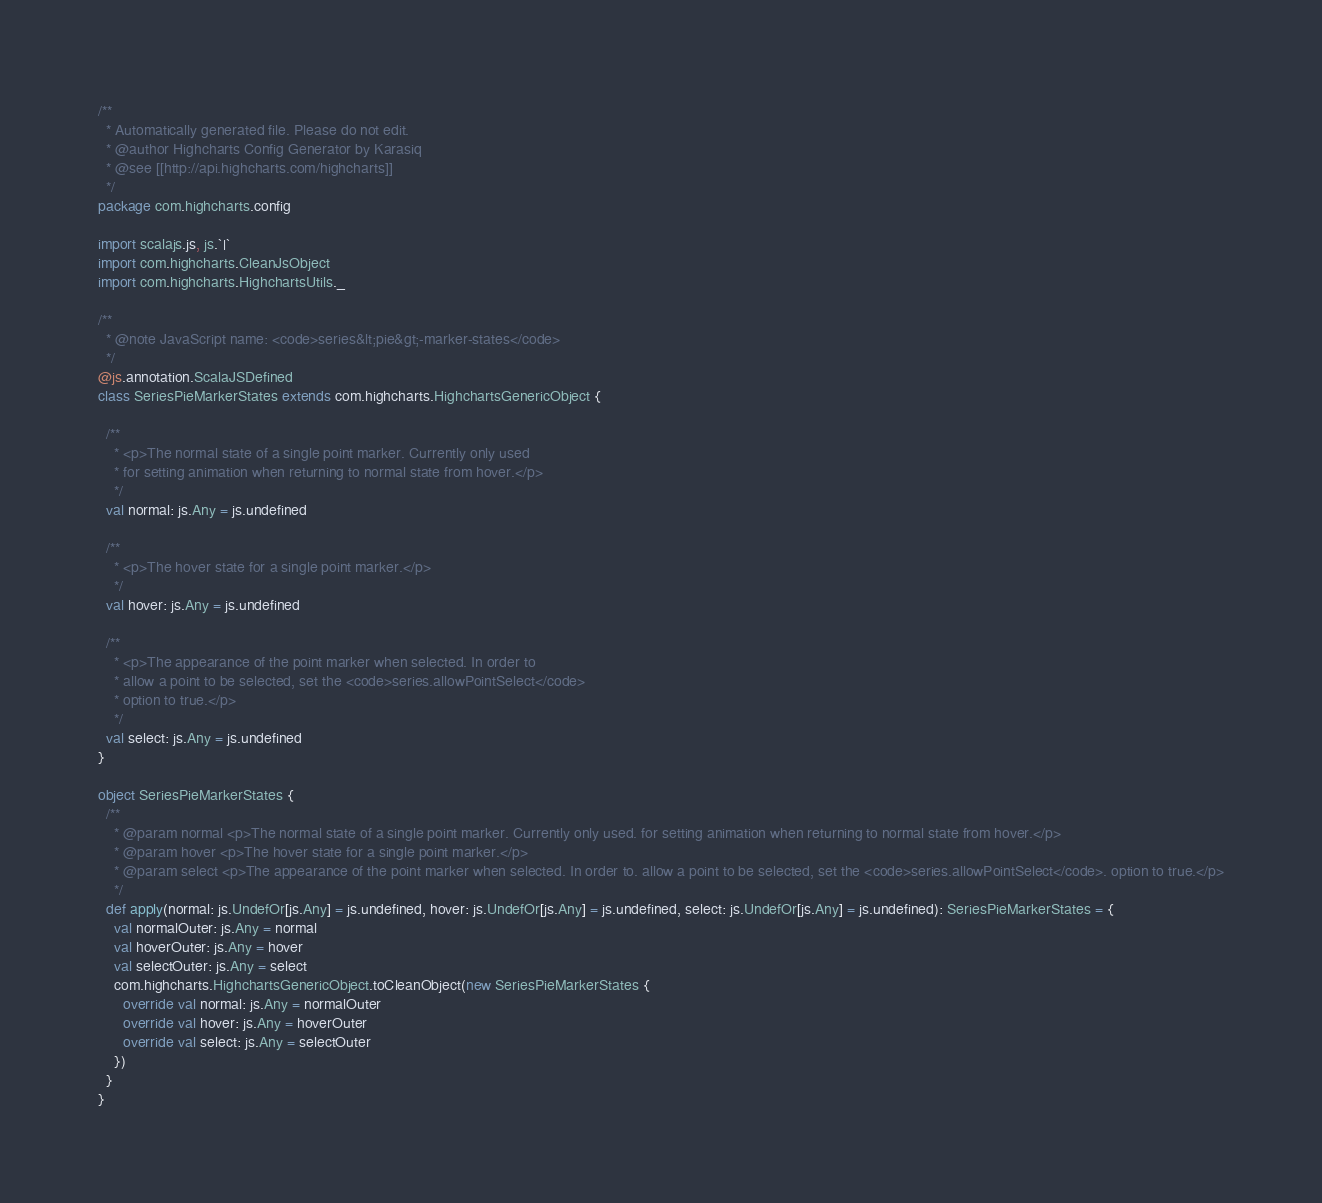Convert code to text. <code><loc_0><loc_0><loc_500><loc_500><_Scala_>/**
  * Automatically generated file. Please do not edit.
  * @author Highcharts Config Generator by Karasiq
  * @see [[http://api.highcharts.com/highcharts]]
  */
package com.highcharts.config

import scalajs.js, js.`|`
import com.highcharts.CleanJsObject
import com.highcharts.HighchartsUtils._

/**
  * @note JavaScript name: <code>series&lt;pie&gt;-marker-states</code>
  */
@js.annotation.ScalaJSDefined
class SeriesPieMarkerStates extends com.highcharts.HighchartsGenericObject {

  /**
    * <p>The normal state of a single point marker. Currently only used
    * for setting animation when returning to normal state from hover.</p>
    */
  val normal: js.Any = js.undefined

  /**
    * <p>The hover state for a single point marker.</p>
    */
  val hover: js.Any = js.undefined

  /**
    * <p>The appearance of the point marker when selected. In order to
    * allow a point to be selected, set the <code>series.allowPointSelect</code>
    * option to true.</p>
    */
  val select: js.Any = js.undefined
}

object SeriesPieMarkerStates {
  /**
    * @param normal <p>The normal state of a single point marker. Currently only used. for setting animation when returning to normal state from hover.</p>
    * @param hover <p>The hover state for a single point marker.</p>
    * @param select <p>The appearance of the point marker when selected. In order to. allow a point to be selected, set the <code>series.allowPointSelect</code>. option to true.</p>
    */
  def apply(normal: js.UndefOr[js.Any] = js.undefined, hover: js.UndefOr[js.Any] = js.undefined, select: js.UndefOr[js.Any] = js.undefined): SeriesPieMarkerStates = {
    val normalOuter: js.Any = normal
    val hoverOuter: js.Any = hover
    val selectOuter: js.Any = select
    com.highcharts.HighchartsGenericObject.toCleanObject(new SeriesPieMarkerStates {
      override val normal: js.Any = normalOuter
      override val hover: js.Any = hoverOuter
      override val select: js.Any = selectOuter
    })
  }
}
</code> 